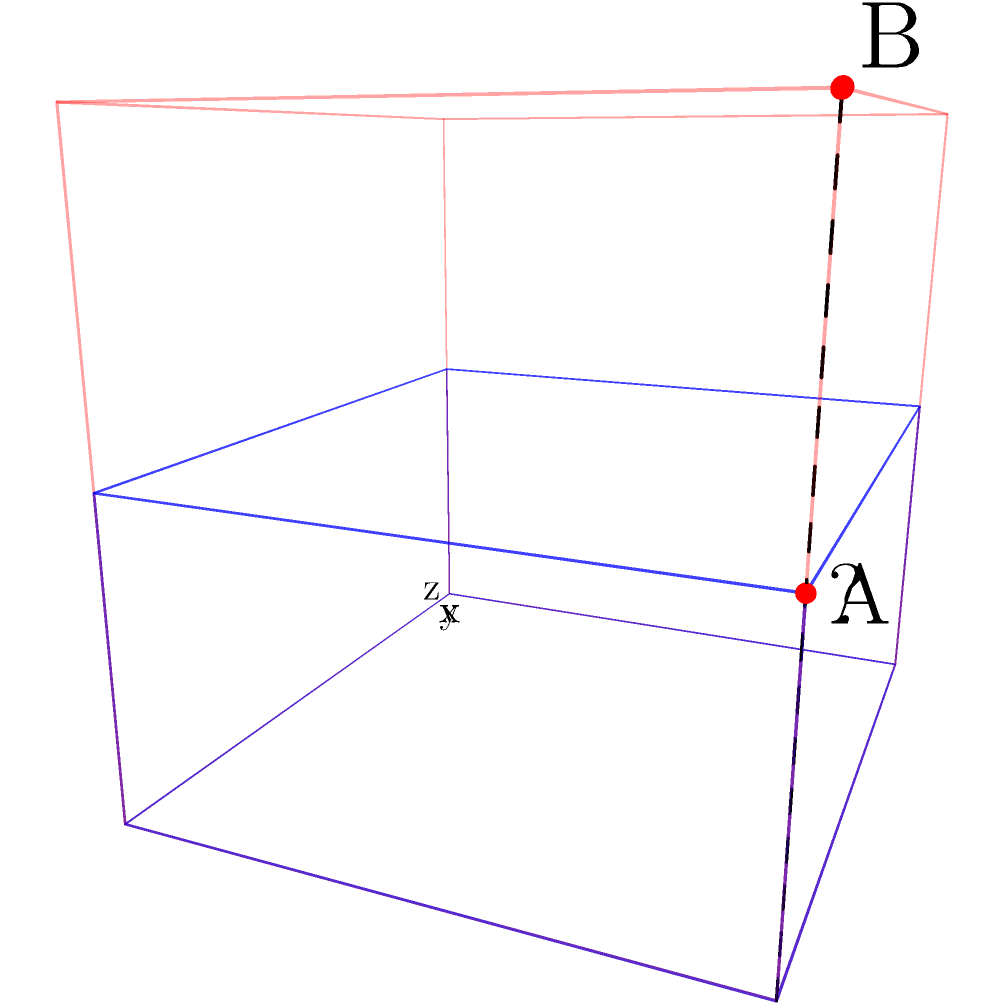In a recent Byzantine excavation, you've uncovered part of a structure with a base measuring 4 meters by 3 meters. The excavated height is 1 meter, but you suspect the original height was greater. Using the 3D coordinate system shown, where the origin (0,0,0) represents the southwest corner at ground level, point A represents the highest point of the excavated structure at (4,3,1), and point B represents your estimate of the original height at (4,3,2), what is the volume of the estimated missing portion in cubic meters? To solve this problem, we need to follow these steps:

1) First, let's identify the dimensions of the structure:
   - Length (x-axis): 4 meters
   - Width (y-axis): 3 meters
   - Excavated height (z-axis): 1 meter
   - Estimated original height: 2 meters

2) The volume of the entire estimated original structure would be:
   $V_{total} = 4m \times 3m \times 2m = 24m^3$

3) The volume of the excavated portion is:
   $V_{excavated} = 4m \times 3m \times 1m = 12m^3$

4) The volume of the missing portion is the difference between these:
   $V_{missing} = V_{total} - V_{excavated}$
   $V_{missing} = 24m^3 - 12m^3 = 12m^3$

5) Therefore, the volume of the estimated missing portion is 12 cubic meters.

This calculation assumes that the structure is a regular rectangular prism, which is a reasonable assumption for many Byzantine buildings. However, as an experienced archaeologist, you would also consider the possibility of more complex architectural features in your final analysis.
Answer: $12m^3$ 